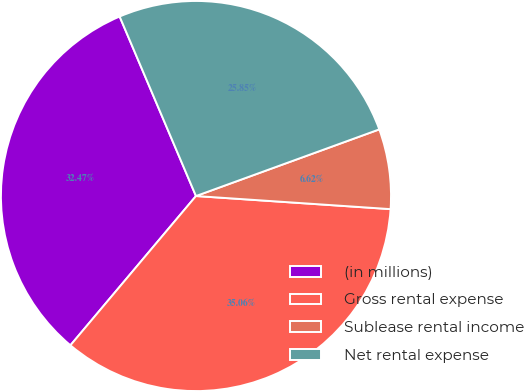Convert chart to OTSL. <chart><loc_0><loc_0><loc_500><loc_500><pie_chart><fcel>(in millions)<fcel>Gross rental expense<fcel>Sublease rental income<fcel>Net rental expense<nl><fcel>32.47%<fcel>35.06%<fcel>6.62%<fcel>25.85%<nl></chart> 